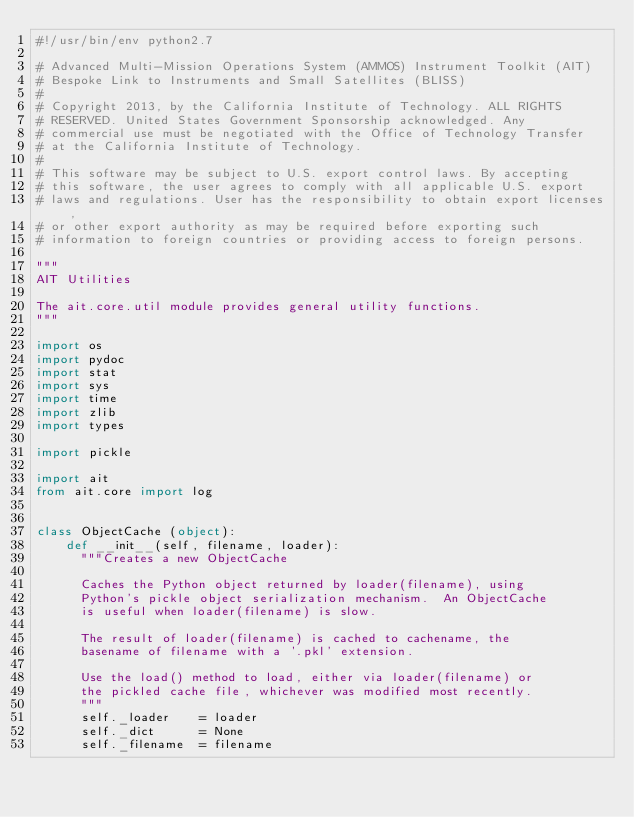<code> <loc_0><loc_0><loc_500><loc_500><_Python_>#!/usr/bin/env python2.7

# Advanced Multi-Mission Operations System (AMMOS) Instrument Toolkit (AIT)
# Bespoke Link to Instruments and Small Satellites (BLISS)
#
# Copyright 2013, by the California Institute of Technology. ALL RIGHTS
# RESERVED. United States Government Sponsorship acknowledged. Any
# commercial use must be negotiated with the Office of Technology Transfer
# at the California Institute of Technology.
#
# This software may be subject to U.S. export control laws. By accepting
# this software, the user agrees to comply with all applicable U.S. export
# laws and regulations. User has the responsibility to obtain export licenses,
# or other export authority as may be required before exporting such
# information to foreign countries or providing access to foreign persons.

"""
AIT Utilities

The ait.core.util module provides general utility functions.
"""

import os
import pydoc
import stat
import sys
import time
import zlib
import types

import pickle

import ait
from ait.core import log


class ObjectCache (object):
    def __init__(self, filename, loader):
      """Creates a new ObjectCache

      Caches the Python object returned by loader(filename), using
      Python's pickle object serialization mechanism.  An ObjectCache
      is useful when loader(filename) is slow.

      The result of loader(filename) is cached to cachename, the
      basename of filename with a '.pkl' extension.

      Use the load() method to load, either via loader(filename) or
      the pickled cache file, whichever was modified most recently.
      """
      self._loader    = loader
      self._dict      = None
      self._filename  = filename</code> 